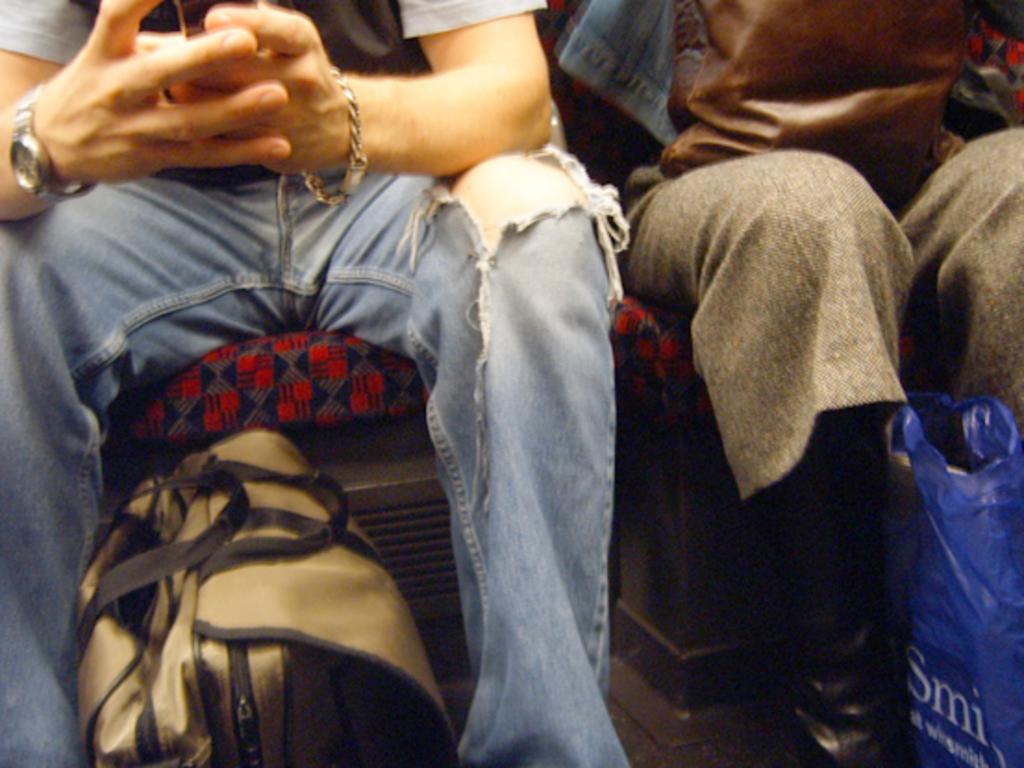How many people are sitting in the image? There are two people sitting on chairs in the image. What is one person doing while sitting? One person is holding a cellphone. What other object can be seen in the image? There is a bag in the image. What might be covering something in the image? There is a cover in the image. What type of wood can be seen on the trail in the image? There is no trail or wood present in the image. What hobbies do the people in the image enjoy? The provided facts do not give any information about the hobbies of the people in the image. 